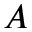Convert formula to latex. <formula><loc_0><loc_0><loc_500><loc_500>A</formula> 